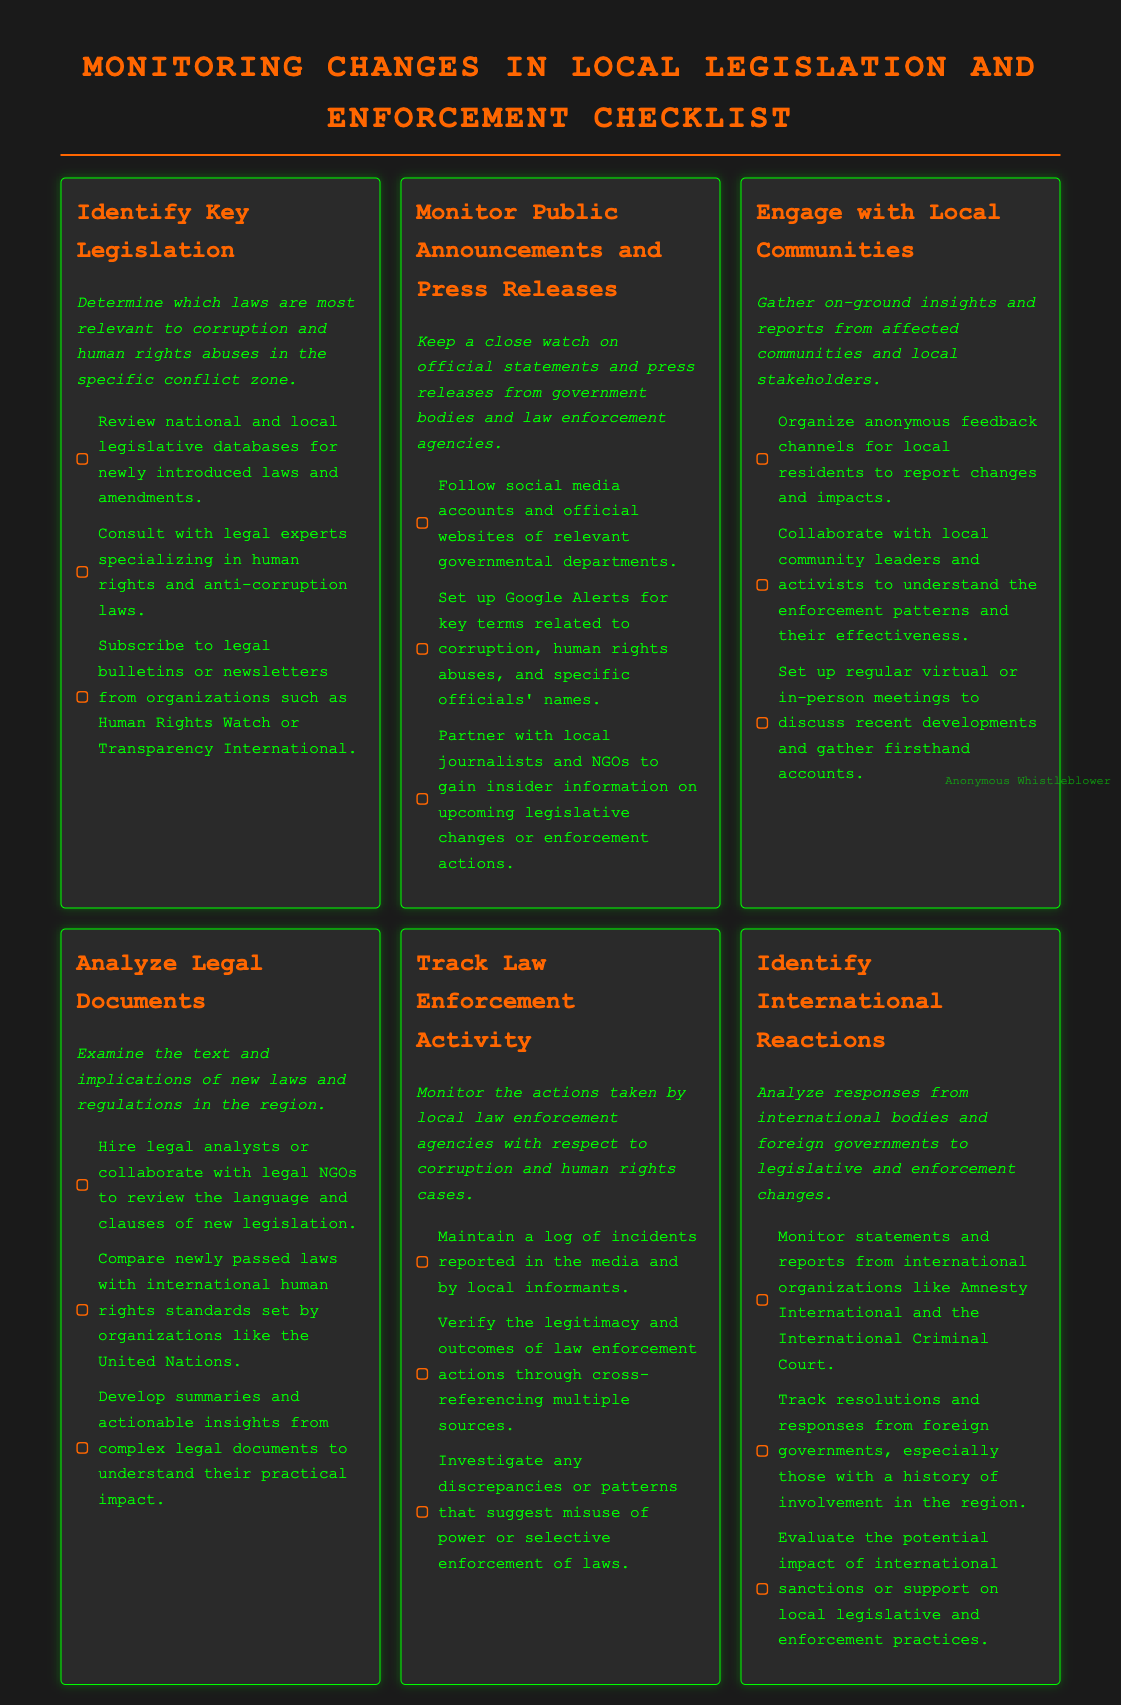What is the title of the document? The title is found at the top of the rendered document, which identifies what the checklist is about.
Answer: Monitoring Changes in Local Legislation and Enforcement Checklist How many main sections are in the checklist? The checklist contains the main sections listed, each with its own title.
Answer: 6 Name one organization suggested for subscribing to legal bulletins. This information is found under the "Identify Key Legislation" section, stating which organizations provide relevant information.
Answer: Human Rights Watch What is a recommended action for monitoring law enforcement activity? This question requires combining information from the specific section about law enforcement to summarize a key action.
Answer: Maintain a log of incidents Which international organization is mentioned in the checklist? The checklist lists an international organization dealing with human rights, which is relevant to the document's context.
Answer: Amnesty International What is the purpose of engaging with local communities? The rationale for this action is outlined in the relevant section, focusing on gathering insights.
Answer: Gather on-ground insights What color is used for the document title? The document uses different colors for various text elements, and this refers specifically to the color of the title text.
Answer: Orange 